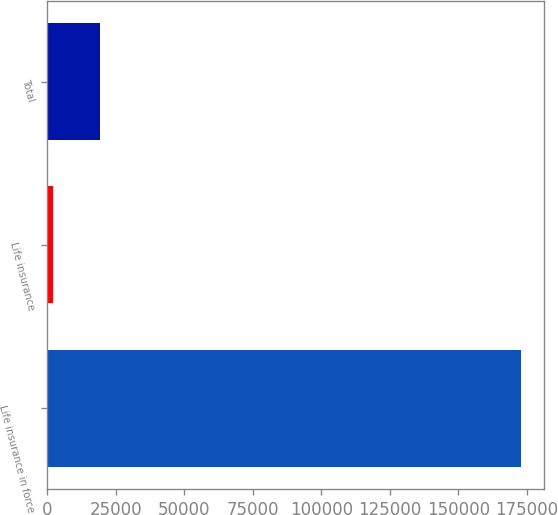Convert chart to OTSL. <chart><loc_0><loc_0><loc_500><loc_500><bar_chart><fcel>Life insurance in force<fcel>Life insurance<fcel>Total<nl><fcel>172726<fcel>2117.6<fcel>19178.4<nl></chart> 